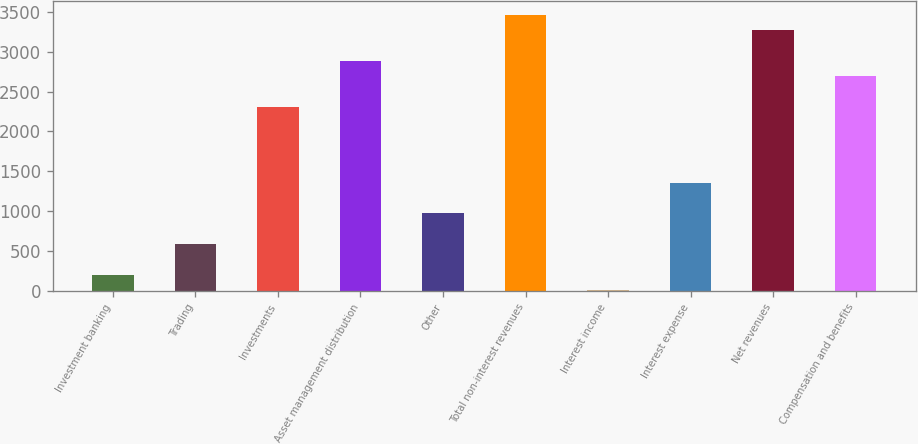<chart> <loc_0><loc_0><loc_500><loc_500><bar_chart><fcel>Investment banking<fcel>Trading<fcel>Investments<fcel>Asset management distribution<fcel>Other<fcel>Total non-interest revenues<fcel>Interest income<fcel>Interest expense<fcel>Net revenues<fcel>Compensation and benefits<nl><fcel>201.8<fcel>585.4<fcel>2311.6<fcel>2887<fcel>969<fcel>3462.4<fcel>10<fcel>1352.6<fcel>3270.6<fcel>2695.2<nl></chart> 